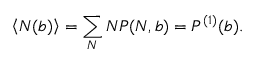Convert formula to latex. <formula><loc_0><loc_0><loc_500><loc_500>\left < N ( b ) \right > = \sum _ { N } N P ( N , b ) = P ^ { ( 1 ) } ( b ) .</formula> 